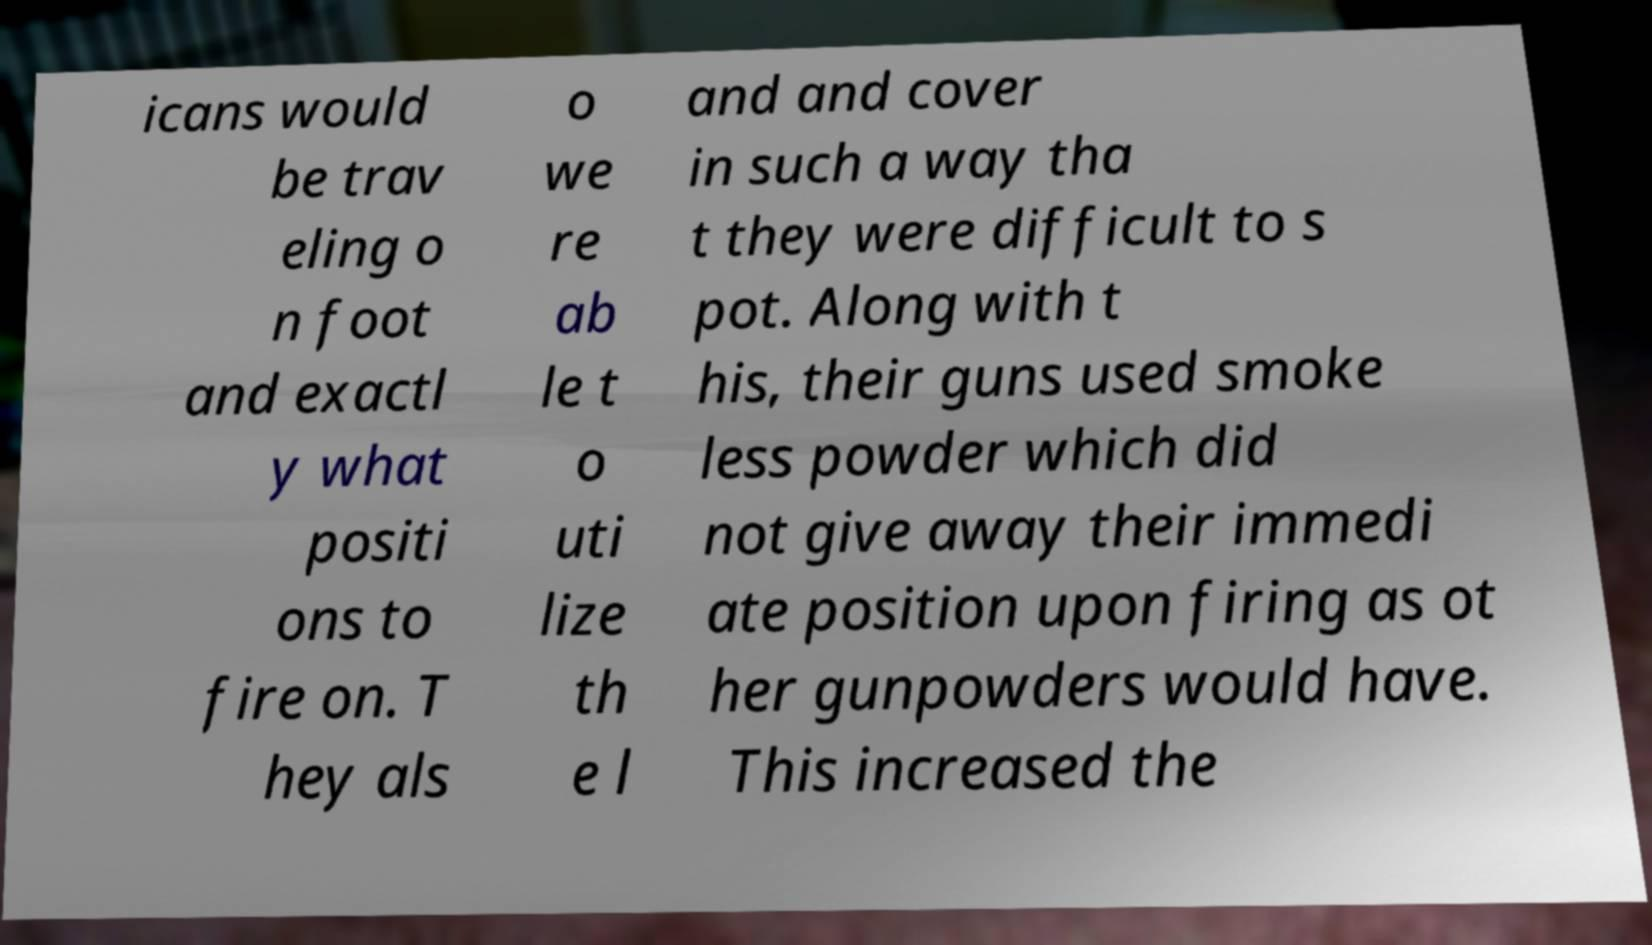Could you assist in decoding the text presented in this image and type it out clearly? icans would be trav eling o n foot and exactl y what positi ons to fire on. T hey als o we re ab le t o uti lize th e l and and cover in such a way tha t they were difficult to s pot. Along with t his, their guns used smoke less powder which did not give away their immedi ate position upon firing as ot her gunpowders would have. This increased the 